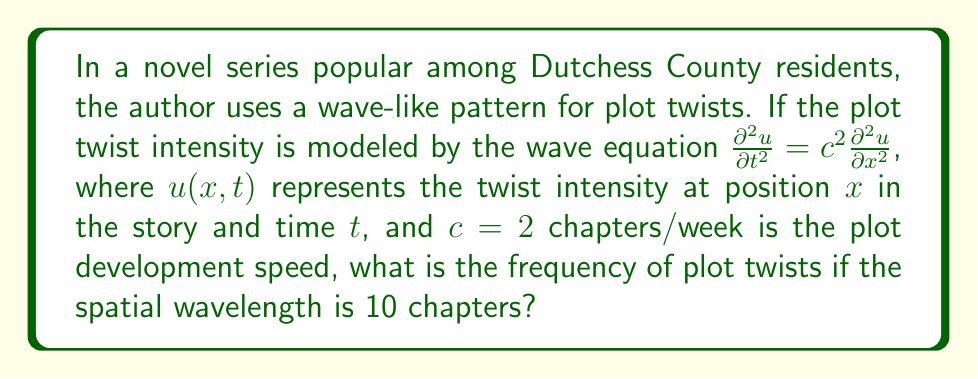Teach me how to tackle this problem. To solve this problem, we'll follow these steps:

1) The general solution to the wave equation is of the form:
   $u(x,t) = A \sin(kx - \omega t)$

2) The wavenumber $k$ is related to the spatial wavelength $\lambda$ by:
   $k = \frac{2\pi}{\lambda}$

3) Given $\lambda = 10$ chapters, we can calculate $k$:
   $k = \frac{2\pi}{10} = \frac{\pi}{5}$ per chapter

4) The wave equation relates $\omega$ and $k$ through the speed $c$:
   $\omega = ck$

5) We can now calculate $\omega$:
   $\omega = 2 \cdot \frac{\pi}{5} = \frac{2\pi}{5}$ radians/week

6) The frequency $f$ is related to $\omega$ by:
   $f = \frac{\omega}{2\pi}$

7) Finally, we can calculate the frequency:
   $f = \frac{\frac{2\pi}{5}}{2\pi} = \frac{1}{5}$ per week

Therefore, the frequency of plot twists is $\frac{1}{5}$ per week or 0.2 plot twists per week.
Answer: $\frac{1}{5}$ plot twists per week 